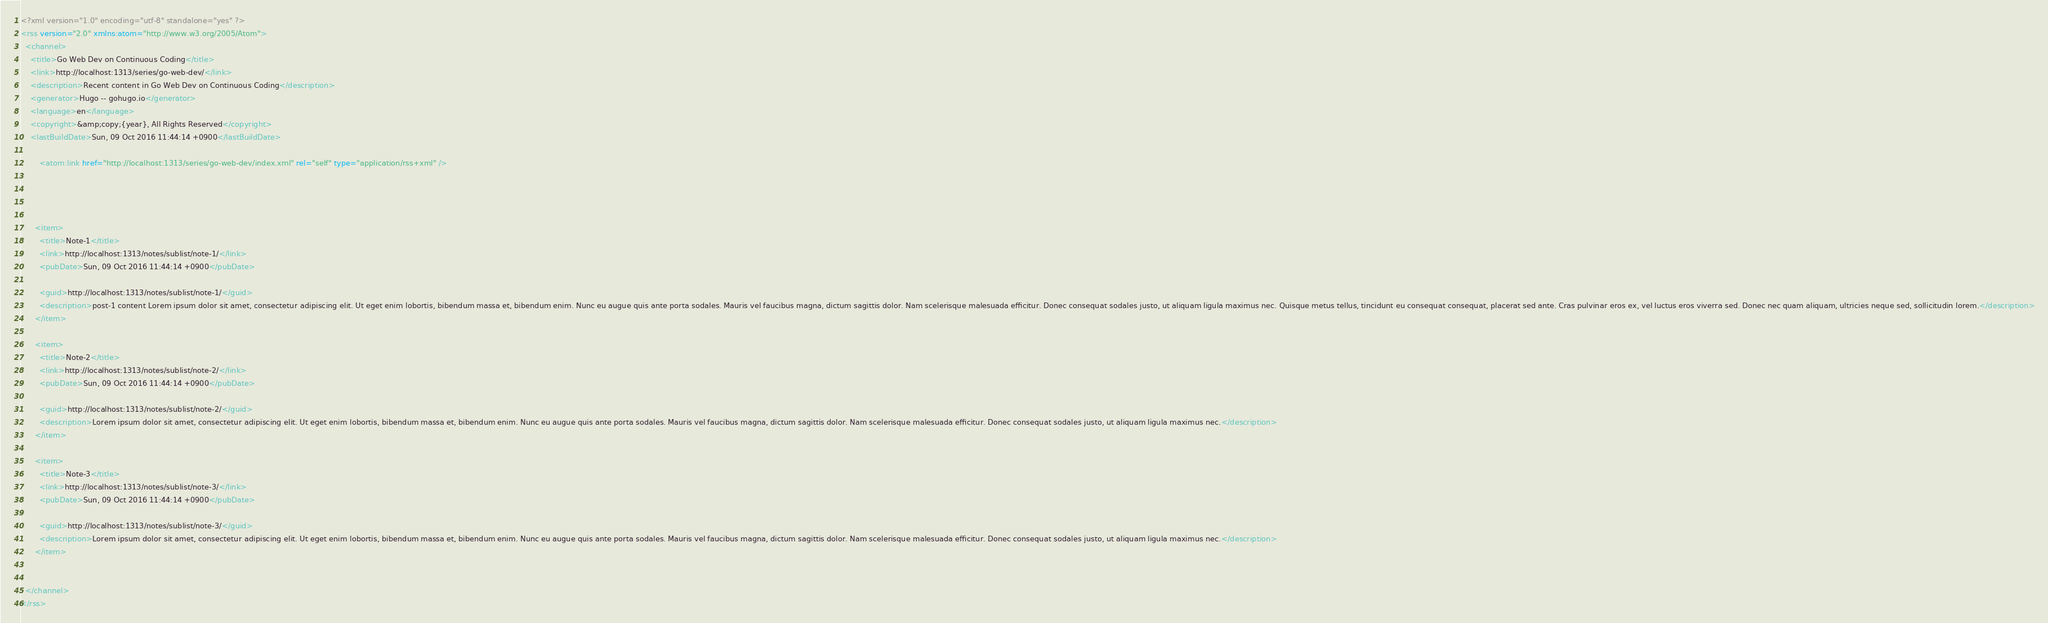Convert code to text. <code><loc_0><loc_0><loc_500><loc_500><_XML_><?xml version="1.0" encoding="utf-8" standalone="yes" ?>
<rss version="2.0" xmlns:atom="http://www.w3.org/2005/Atom">
  <channel>
    <title>Go Web Dev on Continuous Coding</title>
    <link>http://localhost:1313/series/go-web-dev/</link>
    <description>Recent content in Go Web Dev on Continuous Coding</description>
    <generator>Hugo -- gohugo.io</generator>
    <language>en</language>
    <copyright>&amp;copy;{year}, All Rights Reserved</copyright>
    <lastBuildDate>Sun, 09 Oct 2016 11:44:14 +0900</lastBuildDate>
    
        <atom:link href="http://localhost:1313/series/go-web-dev/index.xml" rel="self" type="application/rss+xml" />
    
    
    
      
      <item>
        <title>Note-1</title>
        <link>http://localhost:1313/notes/sublist/note-1/</link>
        <pubDate>Sun, 09 Oct 2016 11:44:14 +0900</pubDate>
        
        <guid>http://localhost:1313/notes/sublist/note-1/</guid>
        <description>post-1 content Lorem ipsum dolor sit amet, consectetur adipiscing elit. Ut eget enim lobortis, bibendum massa et, bibendum enim. Nunc eu augue quis ante porta sodales. Mauris vel faucibus magna, dictum sagittis dolor. Nam scelerisque malesuada efficitur. Donec consequat sodales justo, ut aliquam ligula maximus nec. Quisque metus tellus, tincidunt eu consequat consequat, placerat sed ante. Cras pulvinar eros ex, vel luctus eros viverra sed. Donec nec quam aliquam, ultricies neque sed, sollicitudin lorem.</description>
      </item>
      
      <item>
        <title>Note-2</title>
        <link>http://localhost:1313/notes/sublist/note-2/</link>
        <pubDate>Sun, 09 Oct 2016 11:44:14 +0900</pubDate>
        
        <guid>http://localhost:1313/notes/sublist/note-2/</guid>
        <description>Lorem ipsum dolor sit amet, consectetur adipiscing elit. Ut eget enim lobortis, bibendum massa et, bibendum enim. Nunc eu augue quis ante porta sodales. Mauris vel faucibus magna, dictum sagittis dolor. Nam scelerisque malesuada efficitur. Donec consequat sodales justo, ut aliquam ligula maximus nec.</description>
      </item>
      
      <item>
        <title>Note-3</title>
        <link>http://localhost:1313/notes/sublist/note-3/</link>
        <pubDate>Sun, 09 Oct 2016 11:44:14 +0900</pubDate>
        
        <guid>http://localhost:1313/notes/sublist/note-3/</guid>
        <description>Lorem ipsum dolor sit amet, consectetur adipiscing elit. Ut eget enim lobortis, bibendum massa et, bibendum enim. Nunc eu augue quis ante porta sodales. Mauris vel faucibus magna, dictum sagittis dolor. Nam scelerisque malesuada efficitur. Donec consequat sodales justo, ut aliquam ligula maximus nec.</description>
      </item>
      
    
  </channel>
</rss></code> 